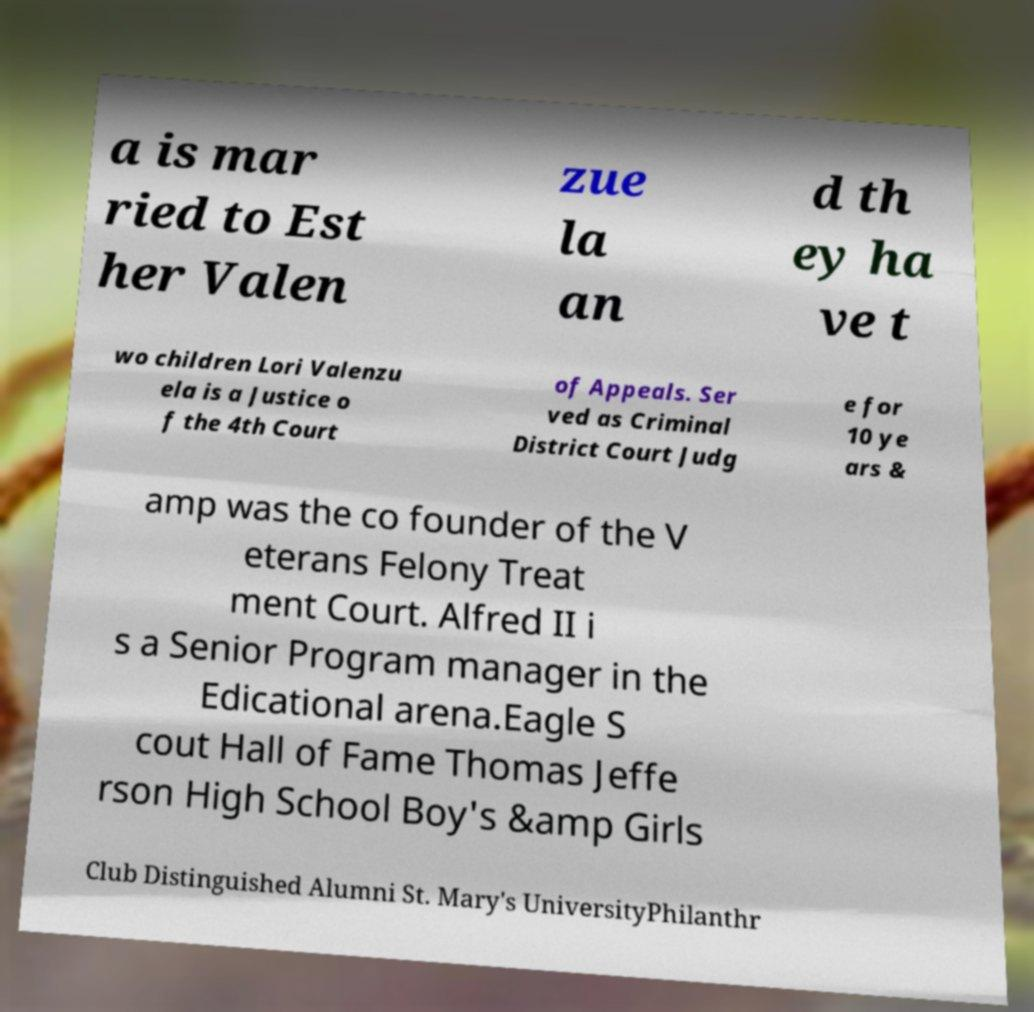Can you read and provide the text displayed in the image?This photo seems to have some interesting text. Can you extract and type it out for me? a is mar ried to Est her Valen zue la an d th ey ha ve t wo children Lori Valenzu ela is a Justice o f the 4th Court of Appeals. Ser ved as Criminal District Court Judg e for 10 ye ars & amp was the co founder of the V eterans Felony Treat ment Court. Alfred II i s a Senior Program manager in the Edicational arena.Eagle S cout Hall of Fame Thomas Jeffe rson High School Boy's &amp Girls Club Distinguished Alumni St. Mary's UniversityPhilanthr 